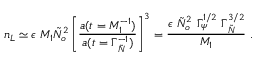<formula> <loc_0><loc_0><loc_500><loc_500>n _ { L } \simeq \epsilon M _ { 1 } \tilde { N } _ { o } ^ { 2 } \left [ { \frac { a ( t = M _ { 1 } ^ { - 1 } ) } { a ( t = \Gamma _ { \tilde { N } } ^ { - 1 } ) } } \right ] ^ { 3 } = { \frac { \epsilon \tilde { N } _ { o } ^ { 2 } \Gamma _ { \psi } ^ { 1 / 2 } \Gamma _ { \tilde { N } } ^ { 3 / 2 } } { M _ { 1 } } } .</formula> 